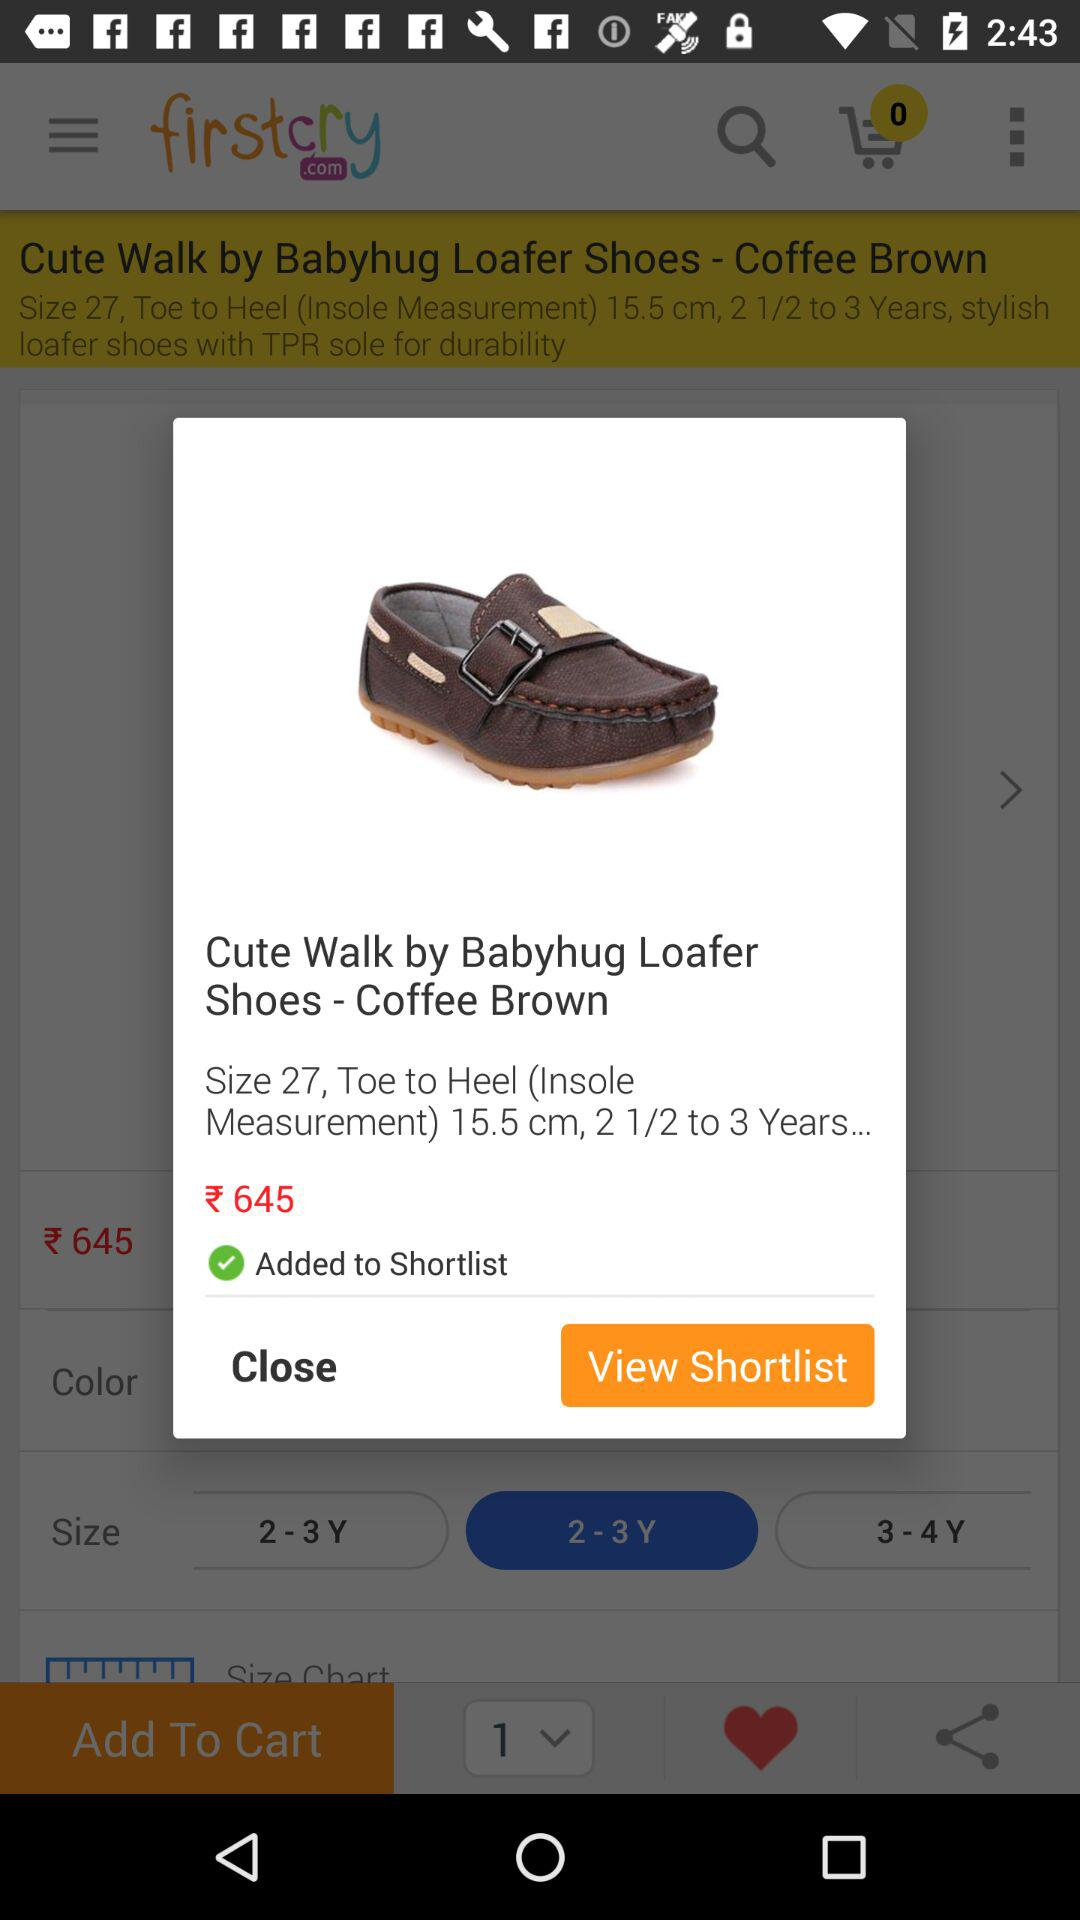What is the name of the application? The name of the application is "FirstCry India - Baby & Kids". 